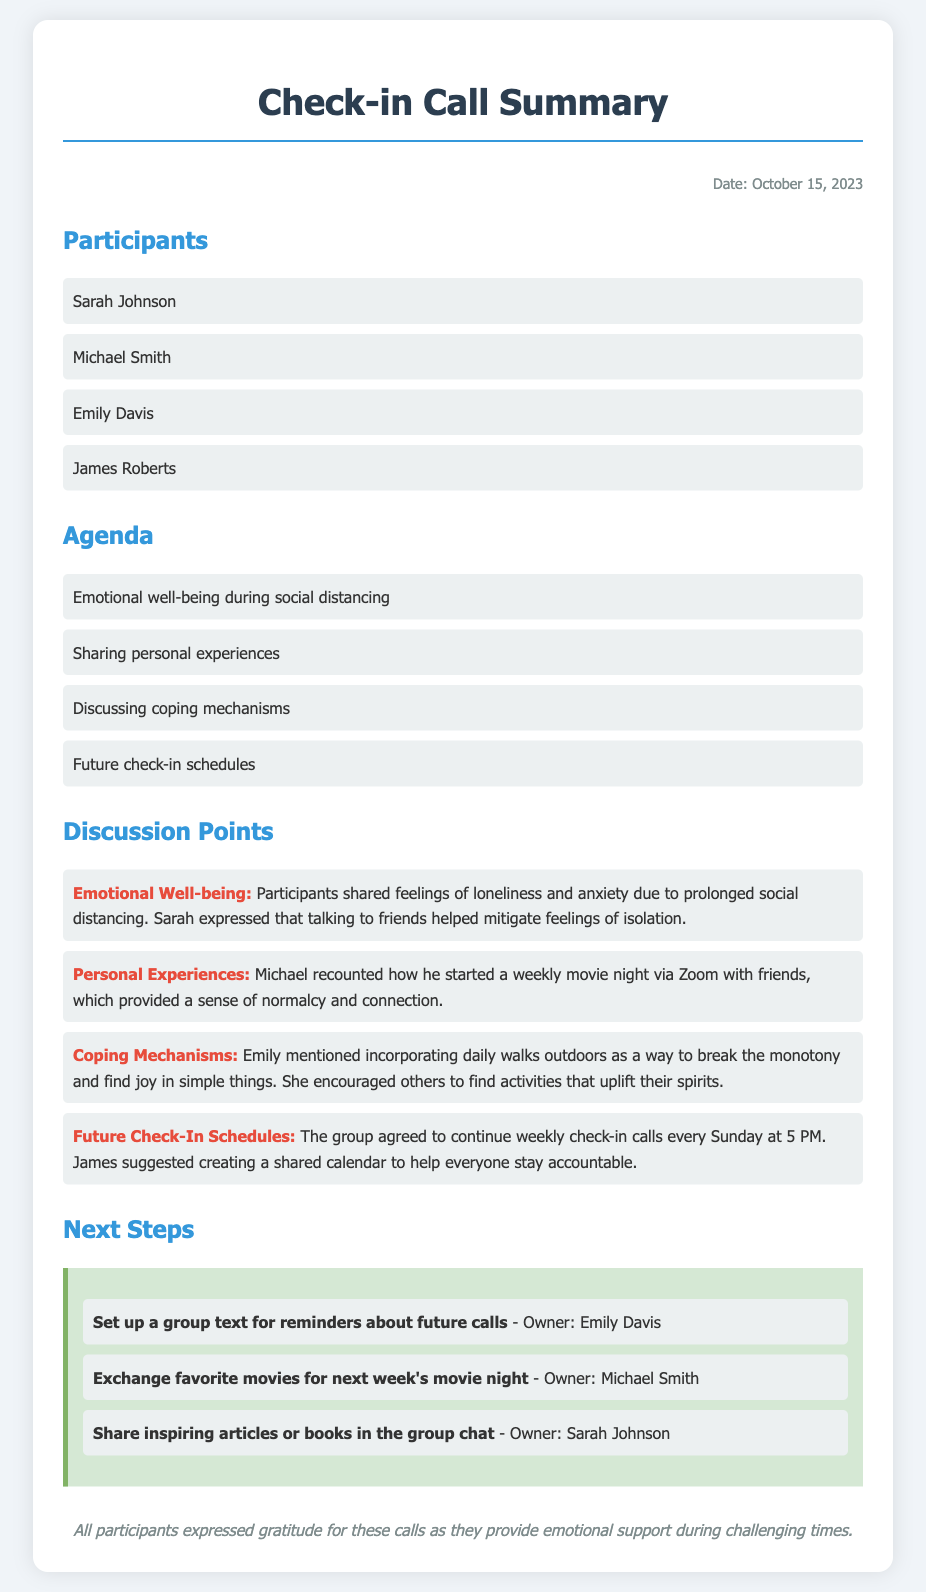What date was the meeting held? The date is explicitly mentioned in the document as October 15, 2023.
Answer: October 15, 2023 How many participants were there in the call? The number of participants is counted from the list provided in the document, which includes four names.
Answer: 4 Who suggested creating a shared calendar? The document states that James suggested the idea during the discussion about future check-in schedules.
Answer: James What coping mechanism did Emily mention? The document specifically notes that Emily mentioned incorporating daily walks outdoors as a way to cope.
Answer: Daily walks How frequently will the group have check-in calls? The frequency of the calls is mentioned as weekly, specifically every Sunday.
Answer: Weekly Which participant will set up a group text for reminders? The document lists that Emily Davis is responsible for setting up the group text.
Answer: Emily Davis What emotion did participants express during the call? The document mentions that participants shared feelings of loneliness and anxiety due to social distancing.
Answer: Loneliness and anxiety What topic provided a sense of normalcy for Michael? The text indicates that Michael's weekly movie night provided a sense of normalcy.
Answer: Weekly movie night 